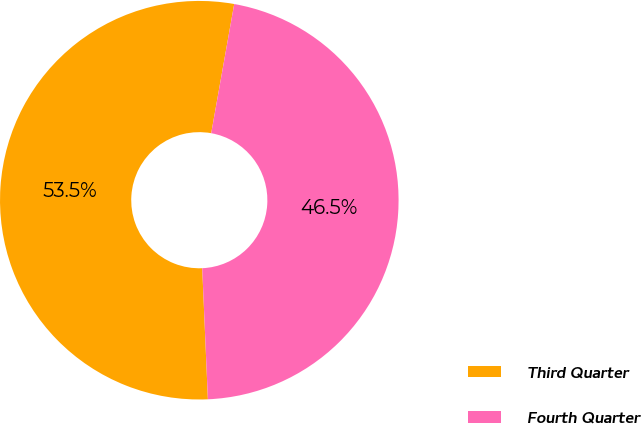<chart> <loc_0><loc_0><loc_500><loc_500><pie_chart><fcel>Third Quarter<fcel>Fourth Quarter<nl><fcel>53.49%<fcel>46.51%<nl></chart> 